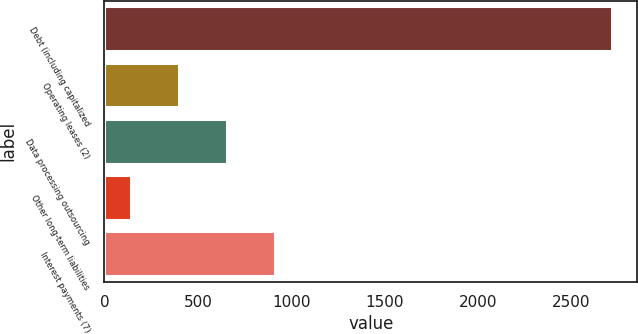Convert chart to OTSL. <chart><loc_0><loc_0><loc_500><loc_500><bar_chart><fcel>Debt (including capitalized<fcel>Operating leases (2)<fcel>Data processing outsourcing<fcel>Other long-term liabilities<fcel>Interest payments (7)<nl><fcel>2715.3<fcel>400.41<fcel>657.62<fcel>143.2<fcel>914.83<nl></chart> 